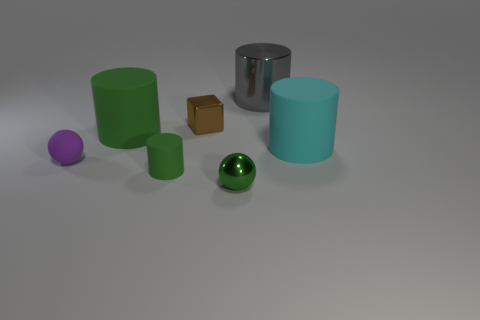Are there any yellow rubber spheres of the same size as the cyan rubber cylinder?
Your answer should be compact. No. Is the gray cylinder made of the same material as the small sphere that is right of the block?
Your answer should be compact. Yes. Is the number of small metallic objects greater than the number of large green rubber balls?
Provide a short and direct response. Yes. How many cubes are either yellow matte things or small green things?
Offer a terse response. 0. What color is the big metallic cylinder?
Give a very brief answer. Gray. There is a matte thing in front of the matte ball; does it have the same size as the cylinder that is behind the cube?
Ensure brevity in your answer.  No. Is the number of brown cubes less than the number of small balls?
Ensure brevity in your answer.  Yes. What number of small brown things are on the left side of the big cyan cylinder?
Your answer should be compact. 1. What is the large green cylinder made of?
Provide a short and direct response. Rubber. Is the color of the shiny ball the same as the small rubber cylinder?
Ensure brevity in your answer.  Yes. 